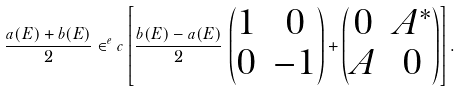<formula> <loc_0><loc_0><loc_500><loc_500>\frac { a ( E ) + b ( E ) } { 2 } \in ^ { e } c \left [ \frac { b ( E ) - a ( E ) } { 2 } \, \begin{pmatrix} 1 & 0 \\ 0 & - 1 \end{pmatrix} + \begin{pmatrix} 0 & A ^ { * } \\ A & 0 \end{pmatrix} \right ] .</formula> 